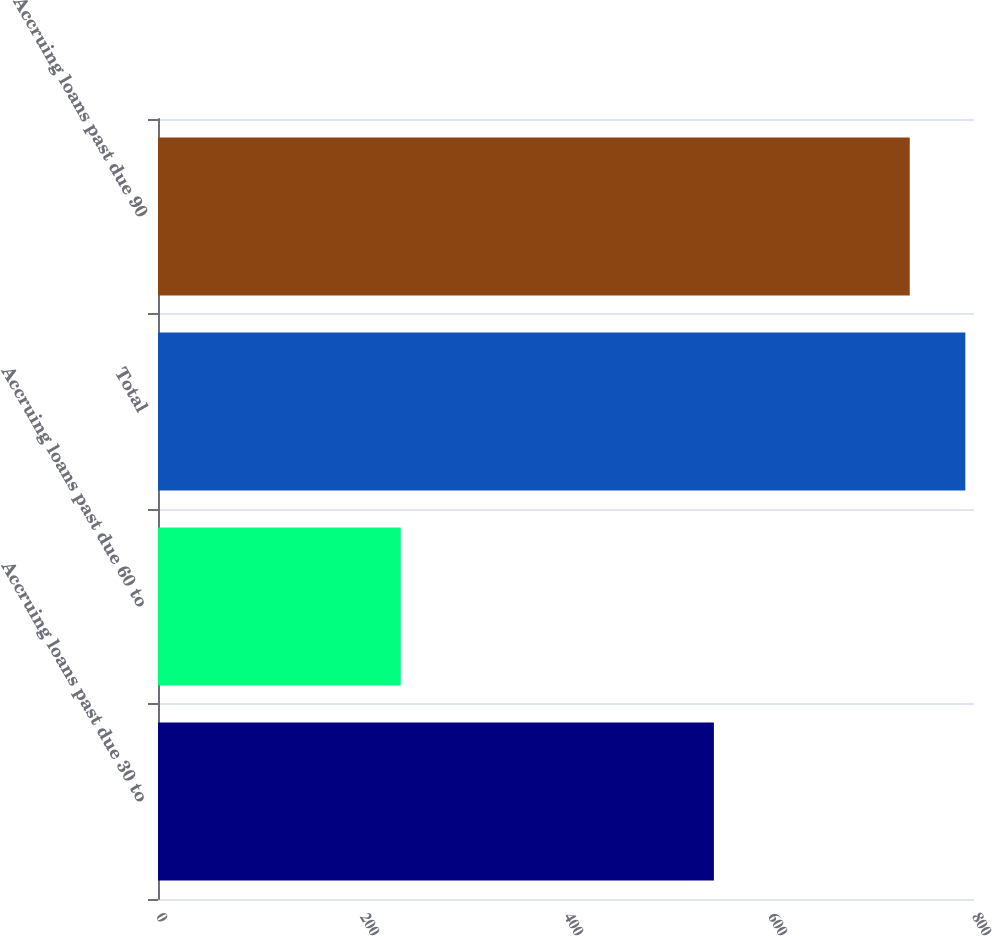Convert chart to OTSL. <chart><loc_0><loc_0><loc_500><loc_500><bar_chart><fcel>Accruing loans past due 30 to<fcel>Accruing loans past due 60 to<fcel>Total<fcel>Accruing loans past due 90<nl><fcel>545<fcel>238<fcel>791.5<fcel>737<nl></chart> 